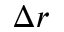Convert formula to latex. <formula><loc_0><loc_0><loc_500><loc_500>\Delta r</formula> 